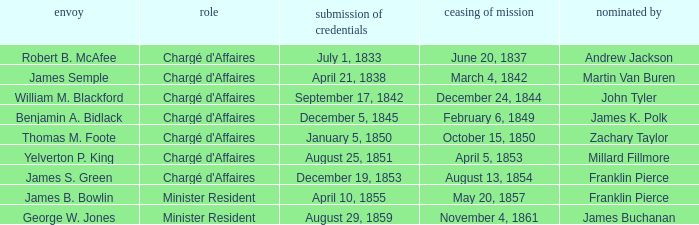What's the Termination of Mission listed that has a Presentation of Credentials for August 29, 1859? November 4, 1861. 